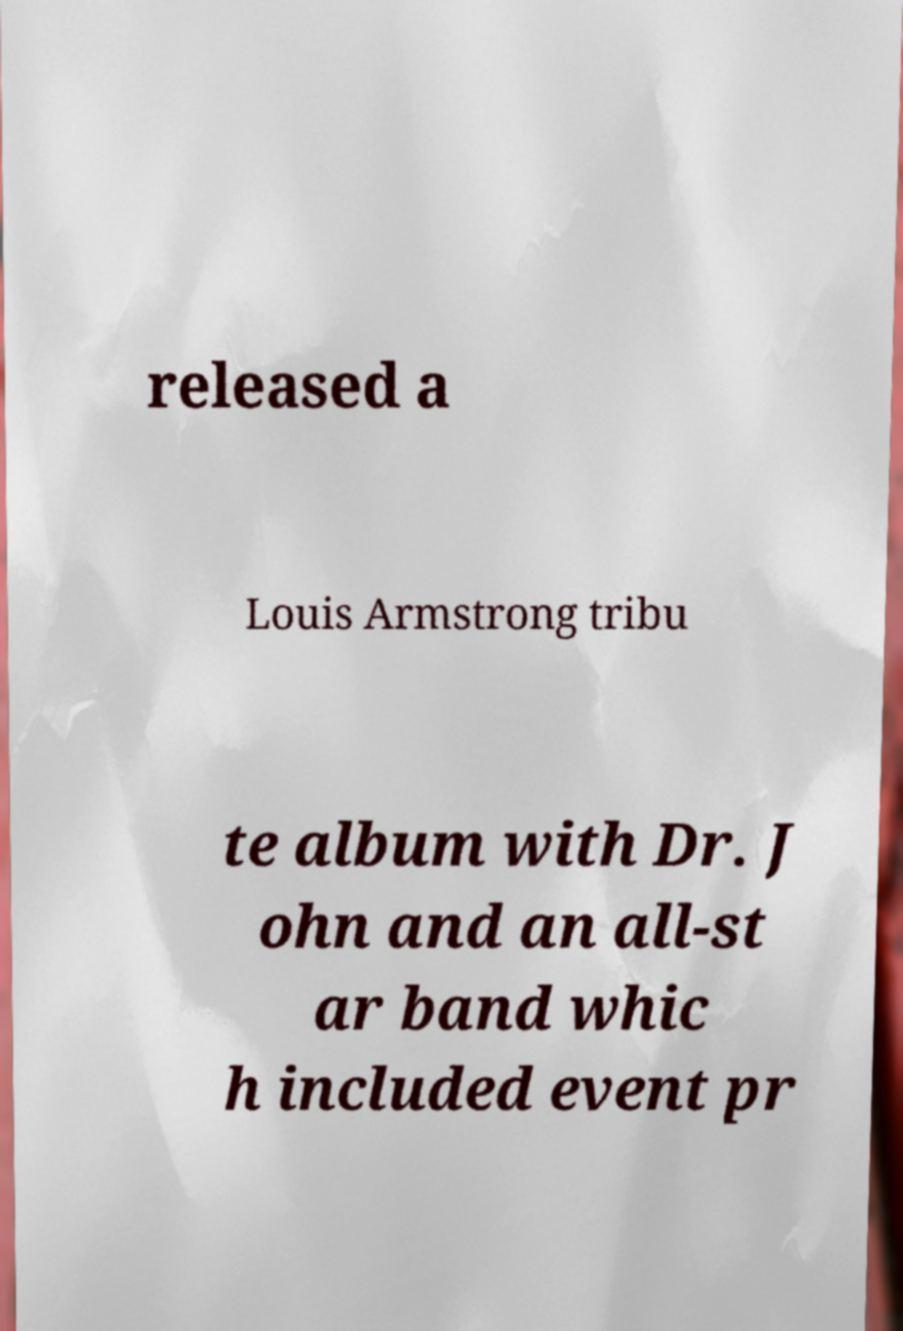Can you accurately transcribe the text from the provided image for me? released a Louis Armstrong tribu te album with Dr. J ohn and an all-st ar band whic h included event pr 